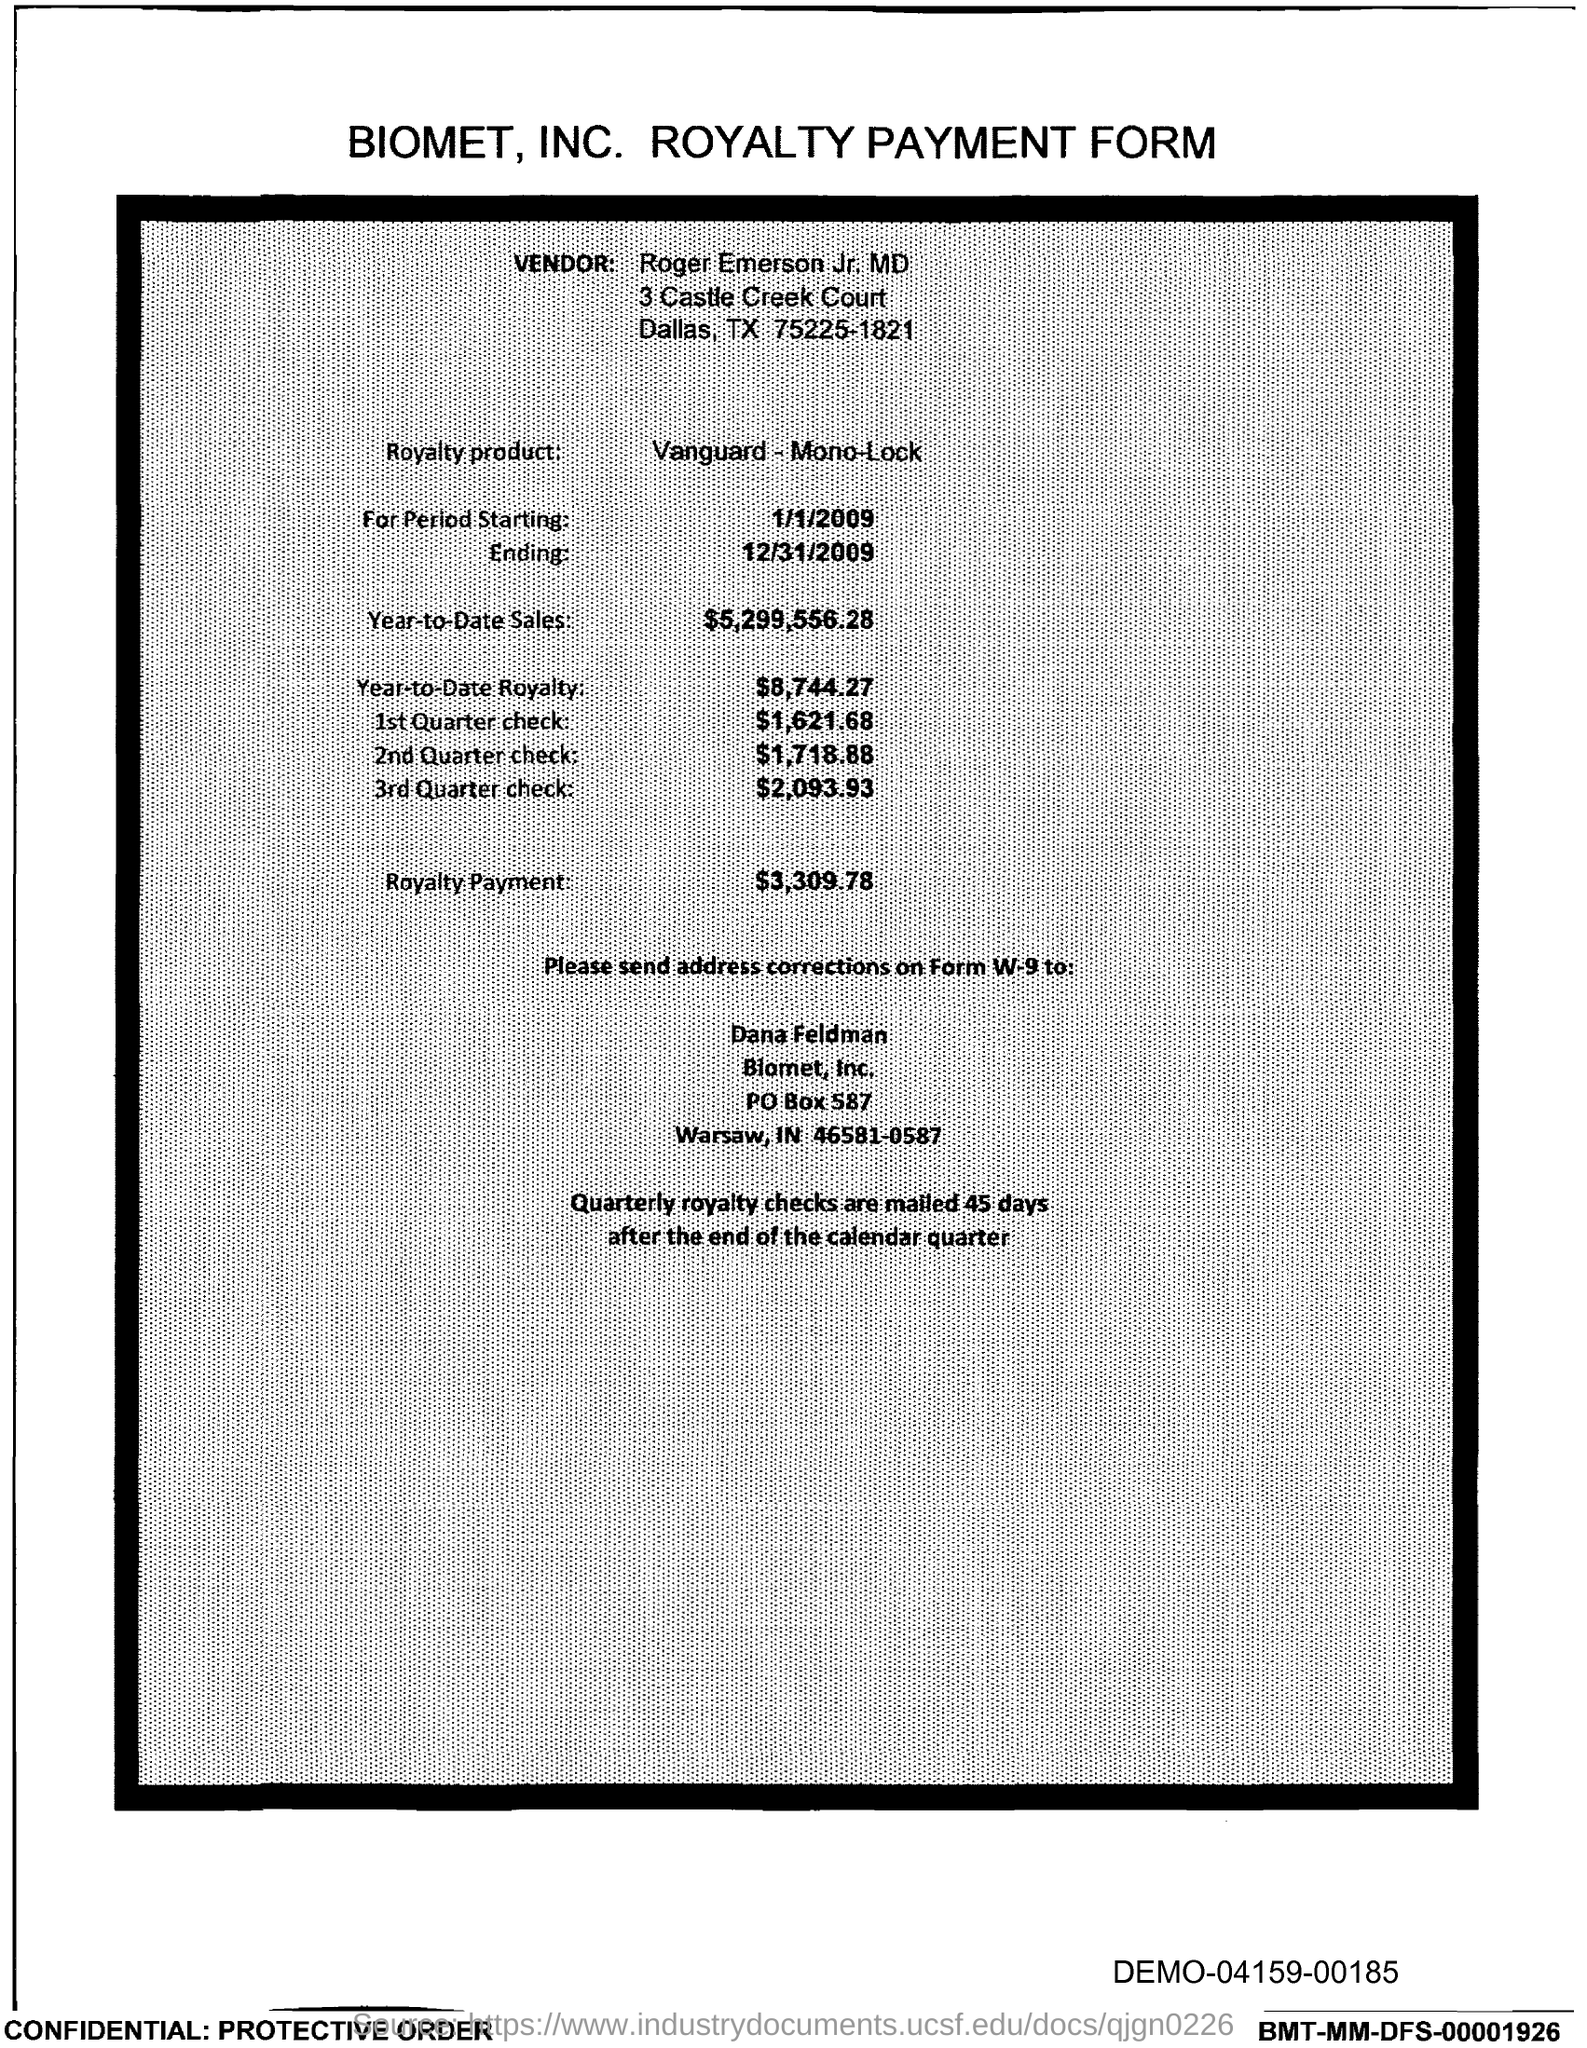What is the PO Box Number mentioned in the document?
Make the answer very short. 587. 